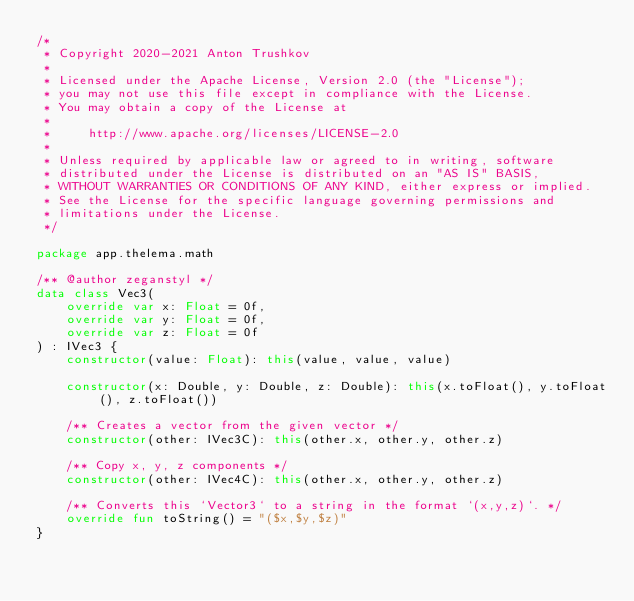<code> <loc_0><loc_0><loc_500><loc_500><_Kotlin_>/*
 * Copyright 2020-2021 Anton Trushkov
 *
 * Licensed under the Apache License, Version 2.0 (the "License");
 * you may not use this file except in compliance with the License.
 * You may obtain a copy of the License at
 *
 *     http://www.apache.org/licenses/LICENSE-2.0
 *
 * Unless required by applicable law or agreed to in writing, software
 * distributed under the License is distributed on an "AS IS" BASIS,
 * WITHOUT WARRANTIES OR CONDITIONS OF ANY KIND, either express or implied.
 * See the License for the specific language governing permissions and
 * limitations under the License.
 */

package app.thelema.math

/** @author zeganstyl */
data class Vec3(
    override var x: Float = 0f,
    override var y: Float = 0f,
    override var z: Float = 0f
) : IVec3 {
    constructor(value: Float): this(value, value, value)

    constructor(x: Double, y: Double, z: Double): this(x.toFloat(), y.toFloat(), z.toFloat())

    /** Creates a vector from the given vector */
    constructor(other: IVec3C): this(other.x, other.y, other.z)

    /** Copy x, y, z components */
    constructor(other: IVec4C): this(other.x, other.y, other.z)

    /** Converts this `Vector3` to a string in the format `(x,y,z)`. */
    override fun toString() = "($x,$y,$z)"
}
</code> 